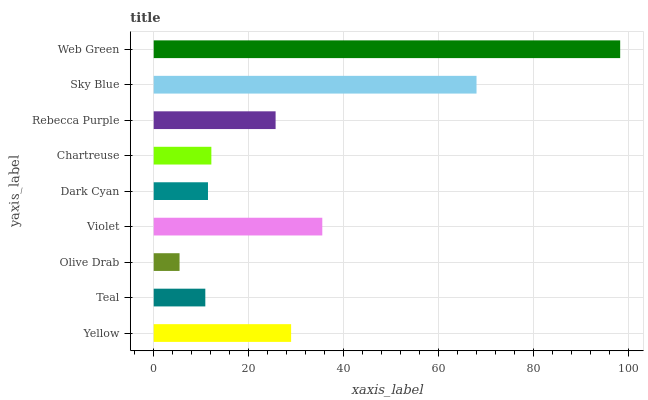Is Olive Drab the minimum?
Answer yes or no. Yes. Is Web Green the maximum?
Answer yes or no. Yes. Is Teal the minimum?
Answer yes or no. No. Is Teal the maximum?
Answer yes or no. No. Is Yellow greater than Teal?
Answer yes or no. Yes. Is Teal less than Yellow?
Answer yes or no. Yes. Is Teal greater than Yellow?
Answer yes or no. No. Is Yellow less than Teal?
Answer yes or no. No. Is Rebecca Purple the high median?
Answer yes or no. Yes. Is Rebecca Purple the low median?
Answer yes or no. Yes. Is Olive Drab the high median?
Answer yes or no. No. Is Sky Blue the low median?
Answer yes or no. No. 